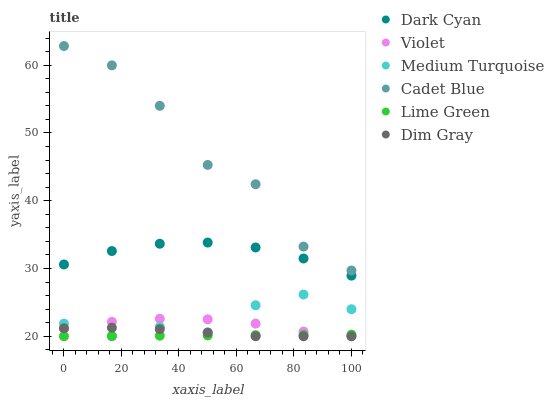Does Lime Green have the minimum area under the curve?
Answer yes or no. Yes. Does Cadet Blue have the maximum area under the curve?
Answer yes or no. Yes. Does Medium Turquoise have the minimum area under the curve?
Answer yes or no. No. Does Medium Turquoise have the maximum area under the curve?
Answer yes or no. No. Is Lime Green the smoothest?
Answer yes or no. Yes. Is Cadet Blue the roughest?
Answer yes or no. Yes. Is Medium Turquoise the smoothest?
Answer yes or no. No. Is Medium Turquoise the roughest?
Answer yes or no. No. Does Dim Gray have the lowest value?
Answer yes or no. Yes. Does Cadet Blue have the lowest value?
Answer yes or no. No. Does Cadet Blue have the highest value?
Answer yes or no. Yes. Does Medium Turquoise have the highest value?
Answer yes or no. No. Is Dim Gray less than Dark Cyan?
Answer yes or no. Yes. Is Cadet Blue greater than Dim Gray?
Answer yes or no. Yes. Does Violet intersect Dim Gray?
Answer yes or no. Yes. Is Violet less than Dim Gray?
Answer yes or no. No. Is Violet greater than Dim Gray?
Answer yes or no. No. Does Dim Gray intersect Dark Cyan?
Answer yes or no. No. 